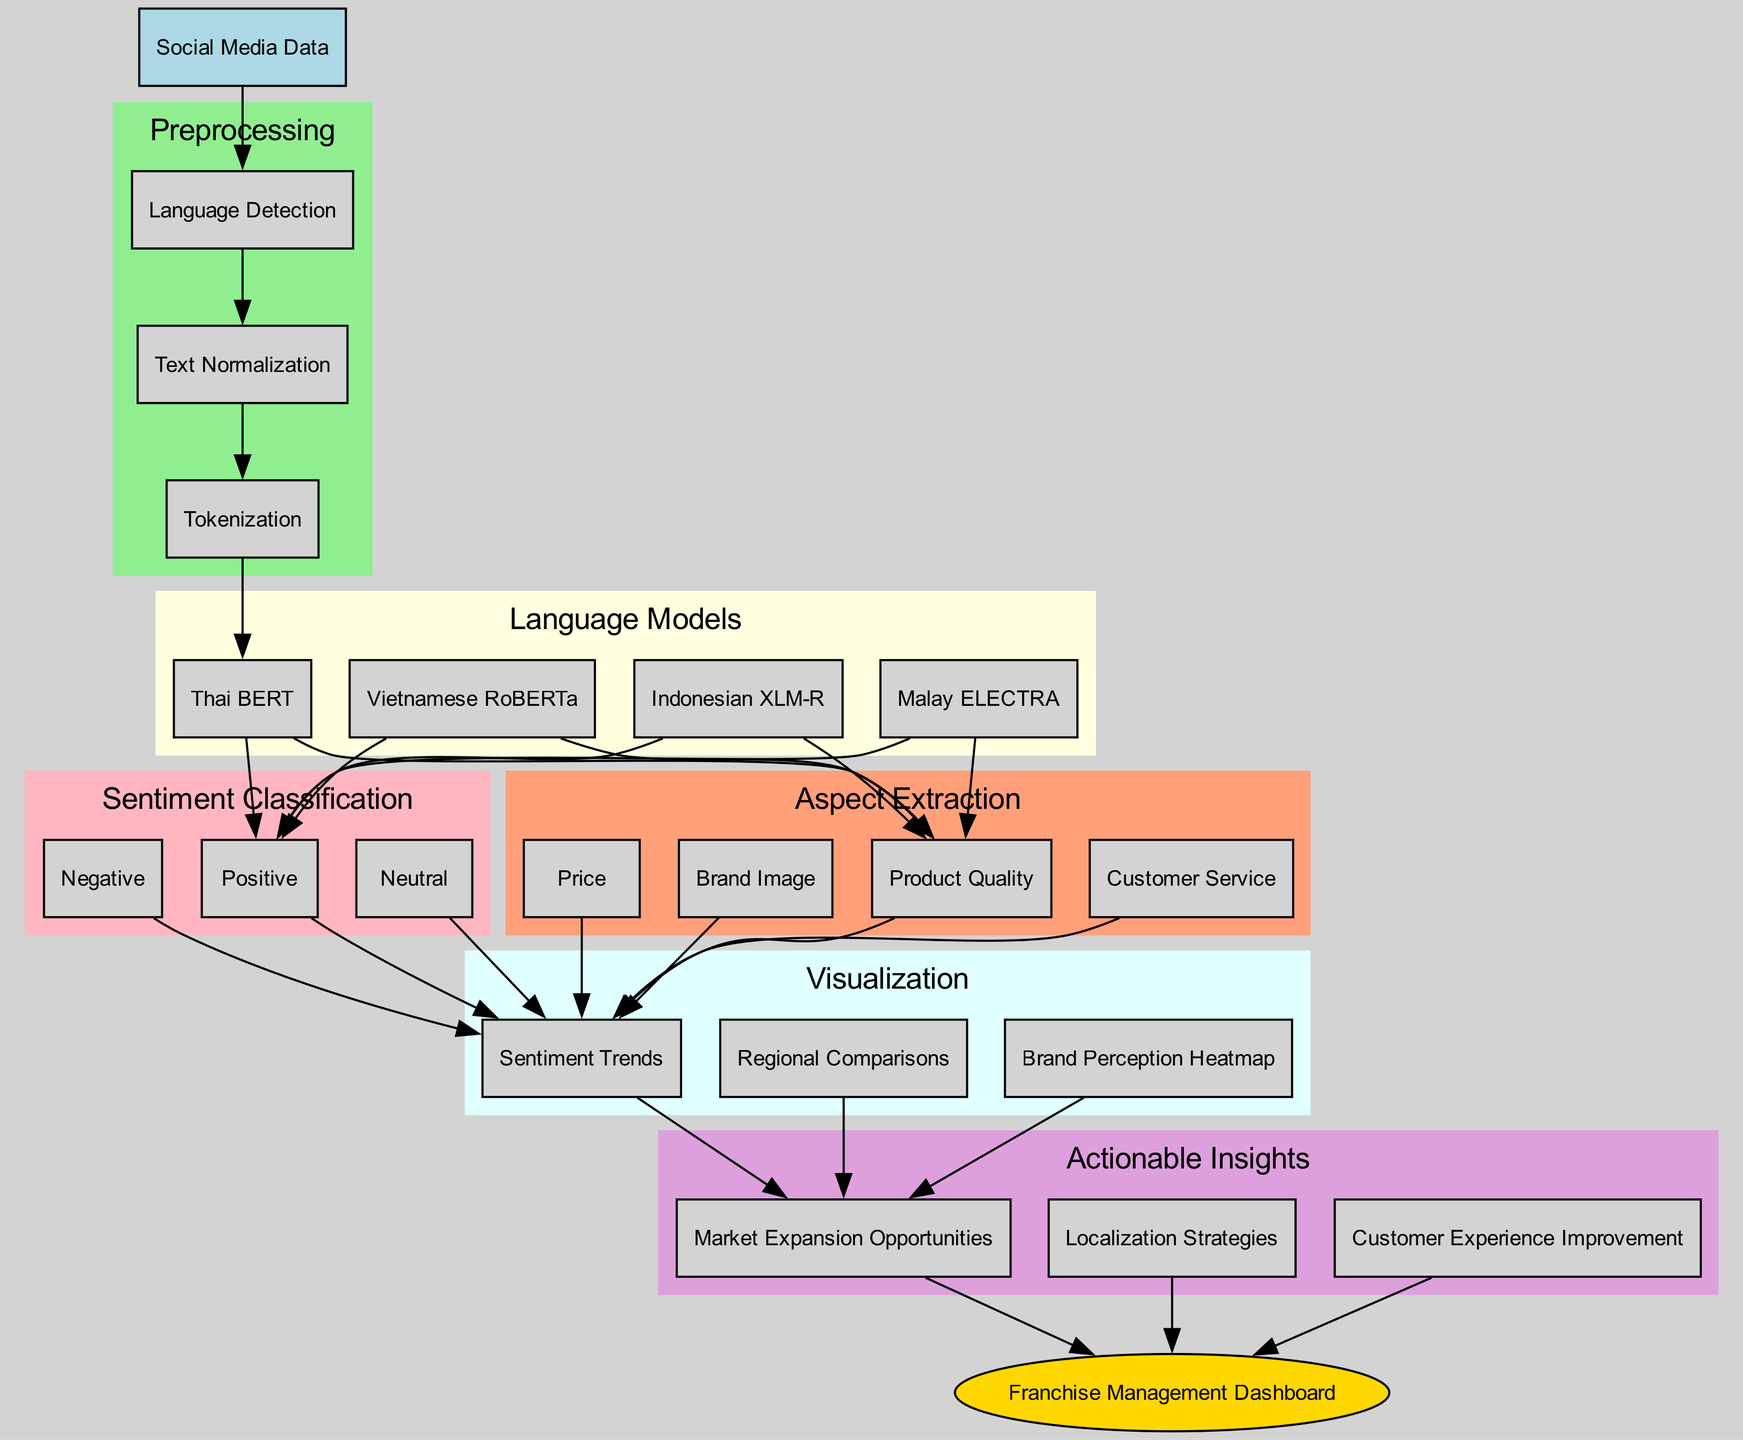What is the first step in the preprocessing phase? The preprocessing phase starts with the first step labeled "Language Detection," indicating that the initial process involves identifying the language of the input social media data.
Answer: Language Detection How many language models are used in the pipeline? The diagram lists four different language models, namely Thai BERT, Vietnamese RoBERTa, Indonesian XLM-R, and Malay ELECTRA, which indicates there are four models in total.
Answer: Four What type of visualization is included in the last step? The diagram indicates the final visualization step includes multiple visualizations, one of which is a "Brand Perception Heatmap," confirming that this particular type of visualization is part of the final output.
Answer: Brand Perception Heatmap Which actionable insight is related to improving customer interaction? Among the actionable insights listed in the diagram, "Customer Experience Improvement" is directly focused on enhancing the interaction with customers based on the analysis.
Answer: Customer Experience Improvement What connects the sentiment classification to visualization? The edges connecting the sentiment classification nodes and visualization nodes show a direct relationship where each sentiment outcome leads to the visualization type, specifically visualizing trends and insights based on the classified sentiments.
Answer: Sentiment Classification Which aspect is focused on the opinion about pricing? The aspect extraction phase includes "Price," which is specifically aimed at analyzing sentiments related to the cost of products or services in the feedback data.
Answer: Price How is the franchise management dashboard represented in the diagram? The integration of insights into the "Franchise Management Dashboard" is depicted as an oval node that signifies the final step where actionable insights are applied to the management framework, serving as the culmination of the analysis.
Answer: Franchise Management Dashboard What does the light pink color in the diagram represent? The light pink color is used in the section labeled "Sentiment Classification," indicating that this cluster represents nodes related to determining the sentiment categories such as Positive, Neutral, and Negative.
Answer: Sentiment Classification How many aspects are extracted in total? The diagram explicitly lists four aspects—Product Quality, Customer Service, Price, and Brand Image—indicating that there are four distinct aspects extracted from the analysis.
Answer: Four 